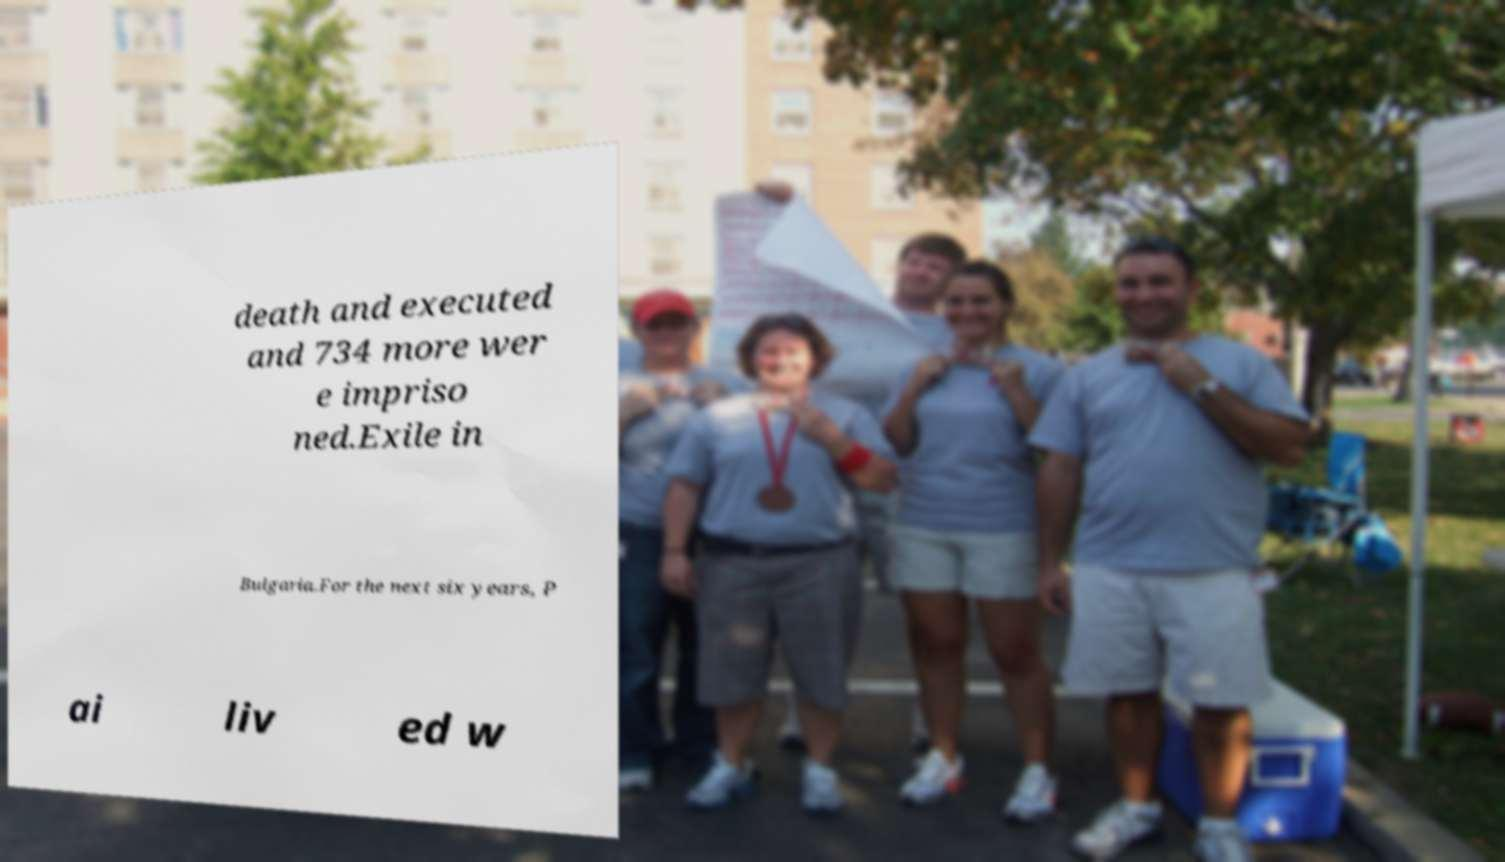Could you extract and type out the text from this image? death and executed and 734 more wer e impriso ned.Exile in Bulgaria.For the next six years, P ai liv ed w 